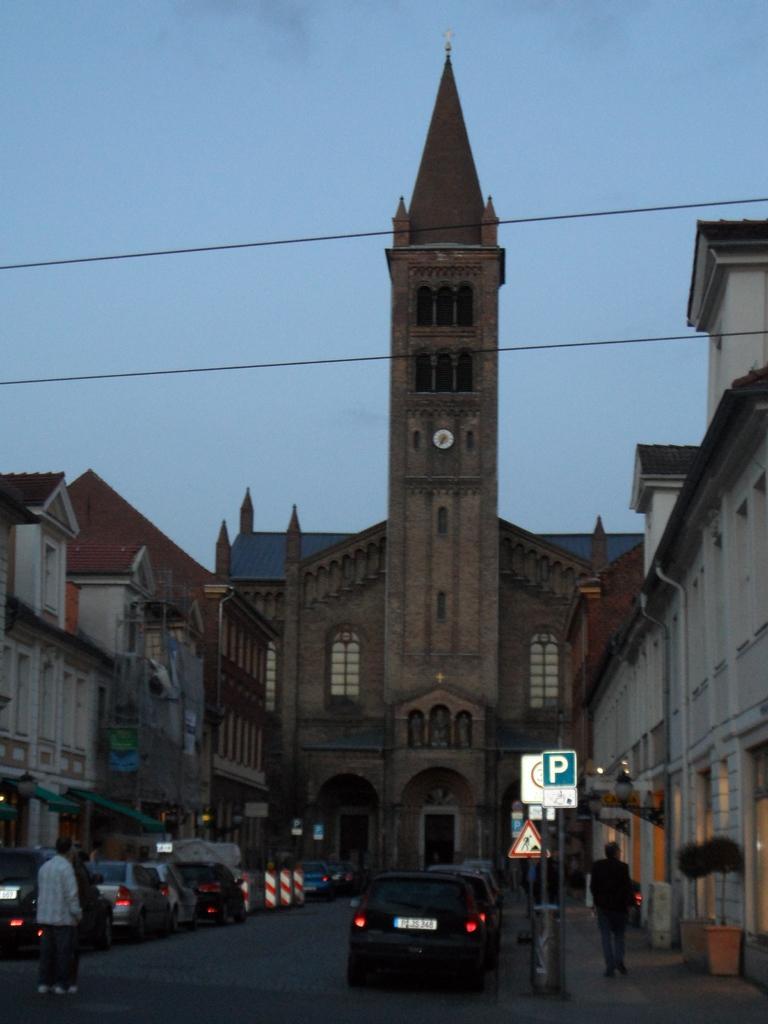Please provide a concise description of this image. There is a person walking and this person standing on the road. We can see vehicles, boards on poles, buildings and wires. In the background we can see sky. 